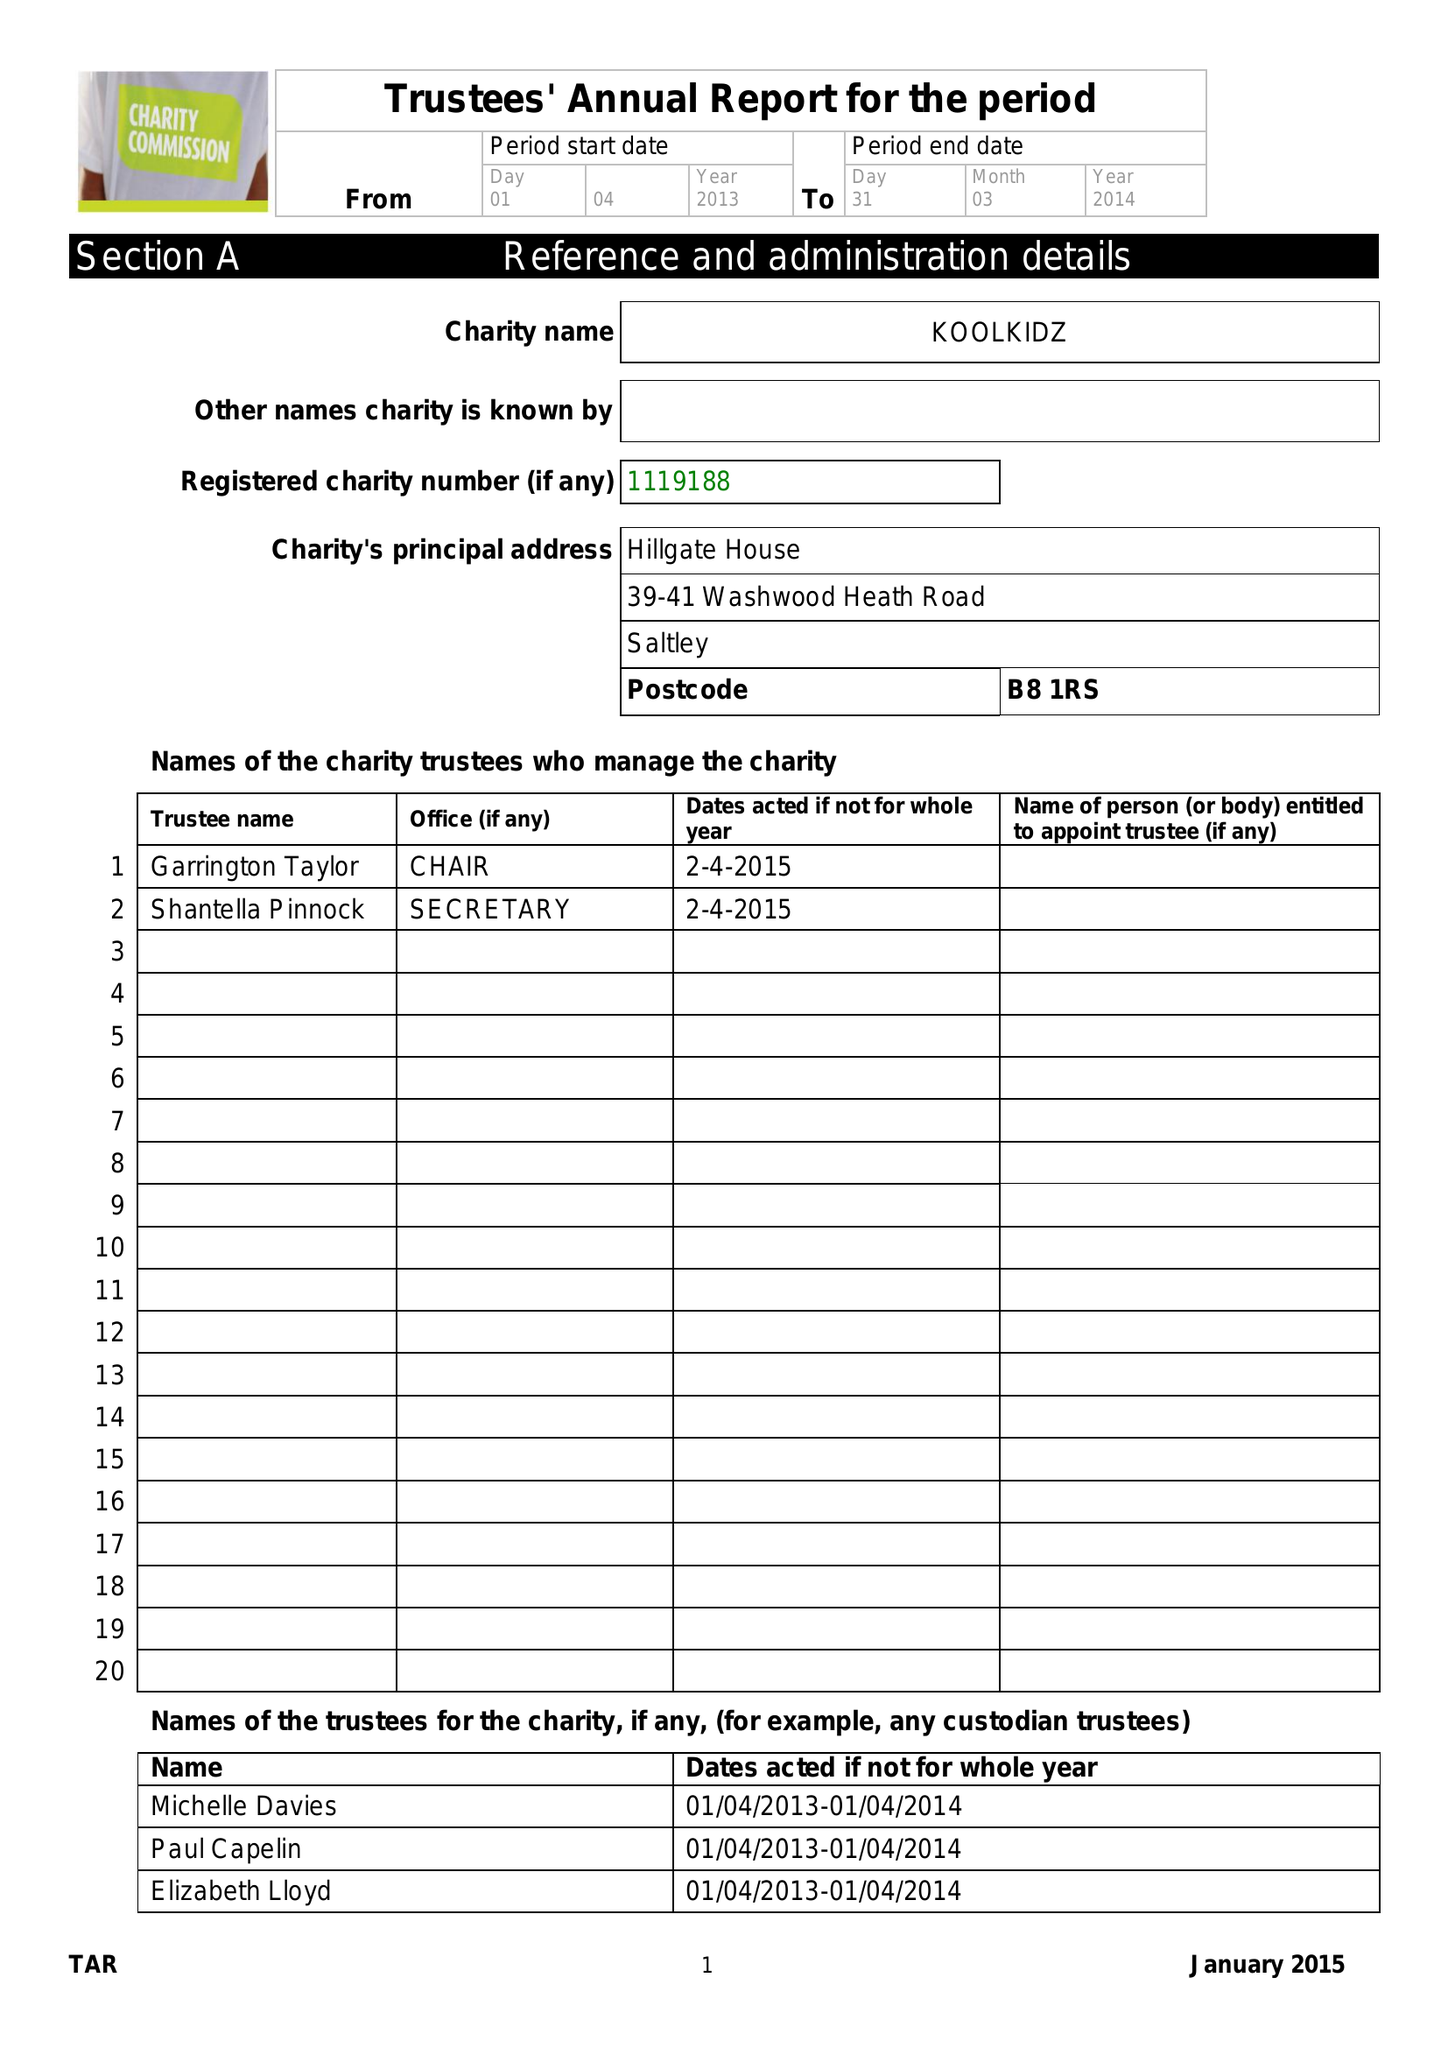What is the value for the spending_annually_in_british_pounds?
Answer the question using a single word or phrase. 268336.00 